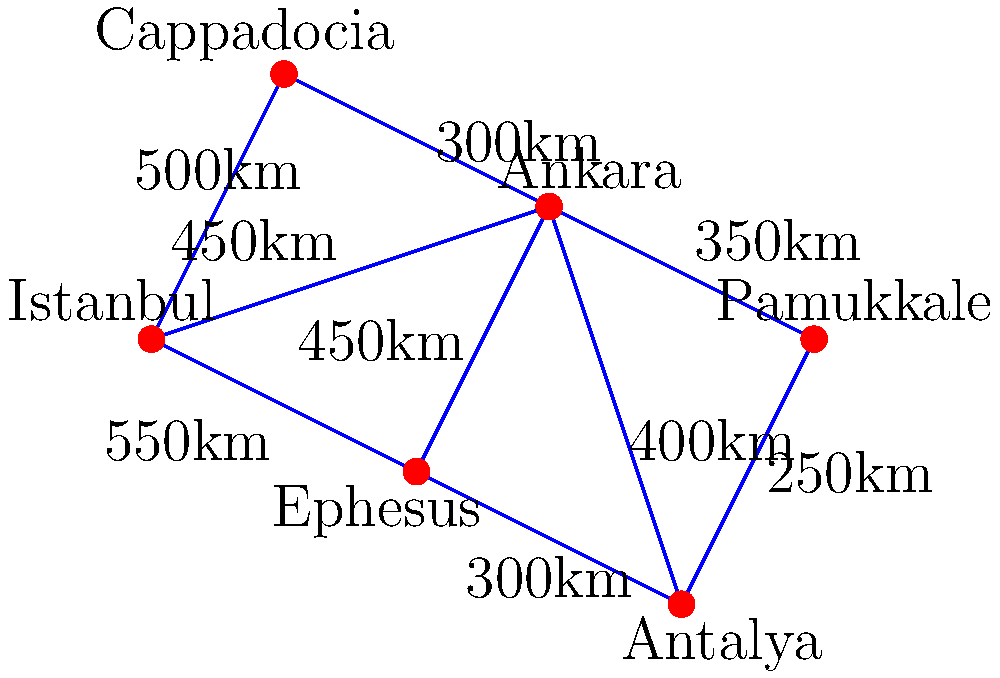Based on the map of popular tourist destinations in Turkey, what is the shortest path from Istanbul to Pamukkale, and what is the total distance of this path? To find the shortest path from Istanbul to Pamukkale, we need to consider all possible routes and calculate their total distances. Let's examine the options step-by-step:

1. Istanbul to Ankara to Pamukkale:
   Istanbul to Ankara: 450 km
   Ankara to Pamukkale: 350 km
   Total: 450 + 350 = 800 km

2. Istanbul to Cappadocia to Ankara to Pamukkale:
   Istanbul to Cappadocia: 500 km
   Cappadocia to Ankara: 300 km
   Ankara to Pamukkale: 350 km
   Total: 500 + 300 + 350 = 1150 km

3. Istanbul to Ephesus to Antalya to Pamukkale:
   Istanbul to Ephesus: 550 km
   Ephesus to Antalya: 300 km
   Antalya to Pamukkale: 250 km
   Total: 550 + 300 + 250 = 1100 km

4. Istanbul to Ankara to Antalya to Pamukkale:
   Istanbul to Ankara: 450 km
   Ankara to Antalya: 400 km
   Antalya to Pamukkale: 250 km
   Total: 450 + 400 + 250 = 1100 km

Comparing all the options, we can see that the shortest path is:
Istanbul → Ankara → Pamukkale, with a total distance of 800 km.
Answer: Istanbul → Ankara → Pamukkale, 800 km 